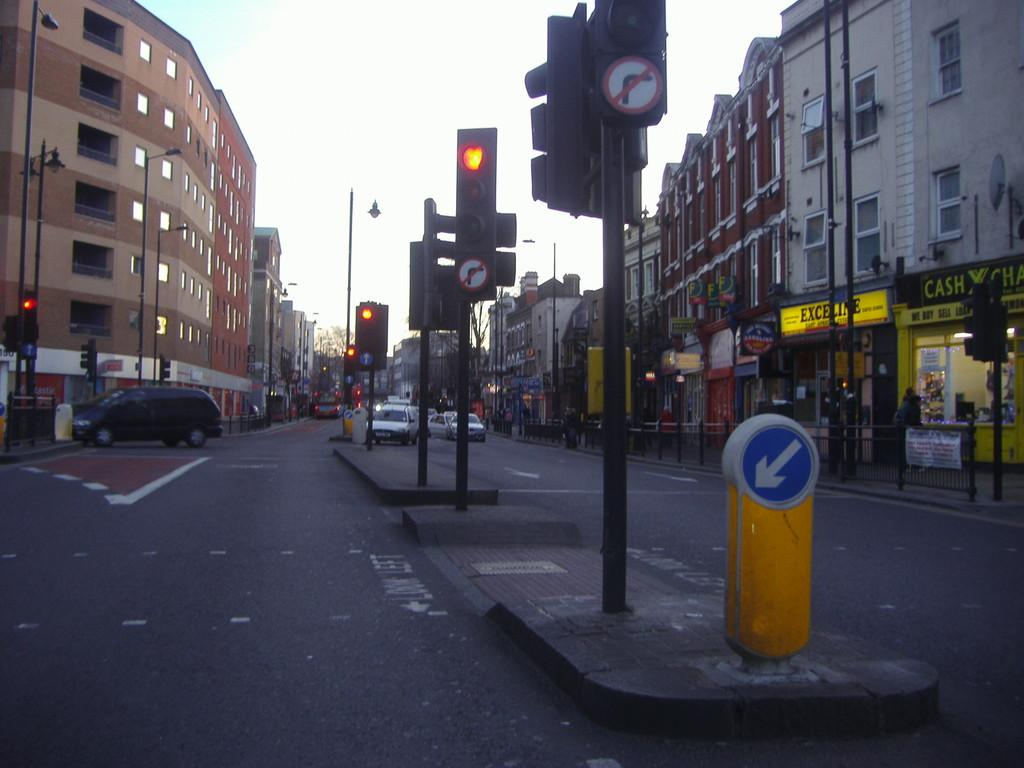<image>
Summarize the visual content of the image. A store has a yellow sign that says Exceline. 